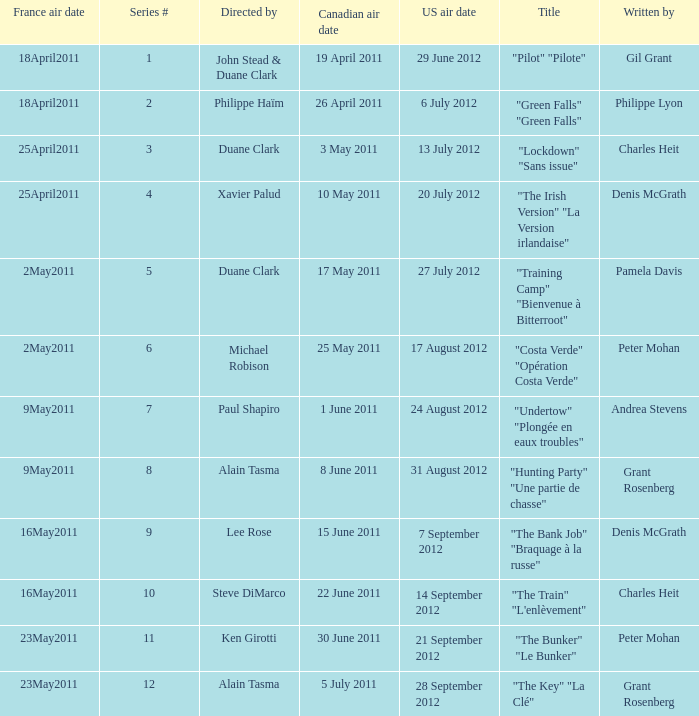What is the US air date when the director is ken girotti? 21 September 2012. 